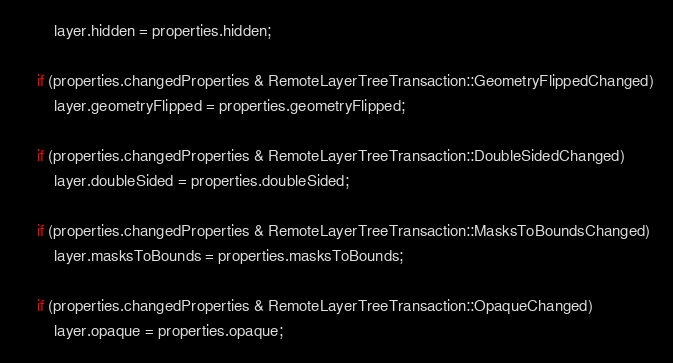<code> <loc_0><loc_0><loc_500><loc_500><_ObjectiveC_>        layer.hidden = properties.hidden;

    if (properties.changedProperties & RemoteLayerTreeTransaction::GeometryFlippedChanged)
        layer.geometryFlipped = properties.geometryFlipped;

    if (properties.changedProperties & RemoteLayerTreeTransaction::DoubleSidedChanged)
        layer.doubleSided = properties.doubleSided;

    if (properties.changedProperties & RemoteLayerTreeTransaction::MasksToBoundsChanged)
        layer.masksToBounds = properties.masksToBounds;

    if (properties.changedProperties & RemoteLayerTreeTransaction::OpaqueChanged)
        layer.opaque = properties.opaque;
</code> 